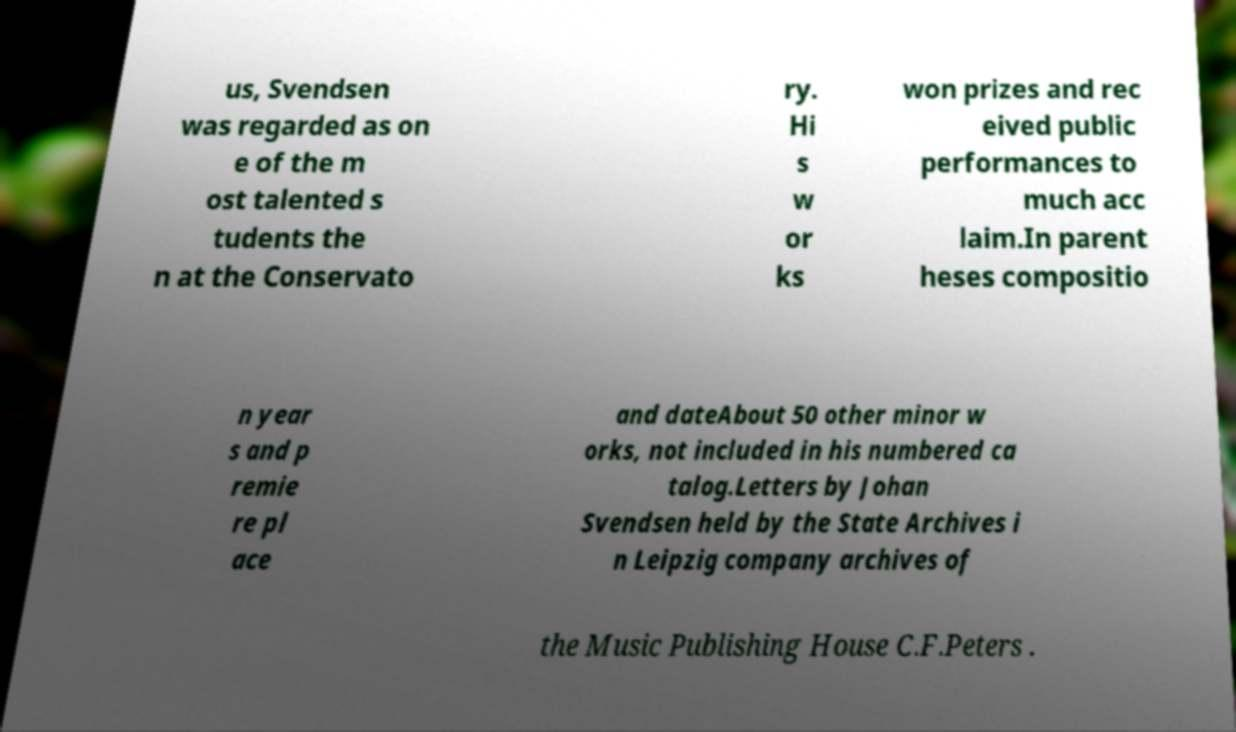Could you extract and type out the text from this image? us, Svendsen was regarded as on e of the m ost talented s tudents the n at the Conservato ry. Hi s w or ks won prizes and rec eived public performances to much acc laim.In parent heses compositio n year s and p remie re pl ace and dateAbout 50 other minor w orks, not included in his numbered ca talog.Letters by Johan Svendsen held by the State Archives i n Leipzig company archives of the Music Publishing House C.F.Peters . 